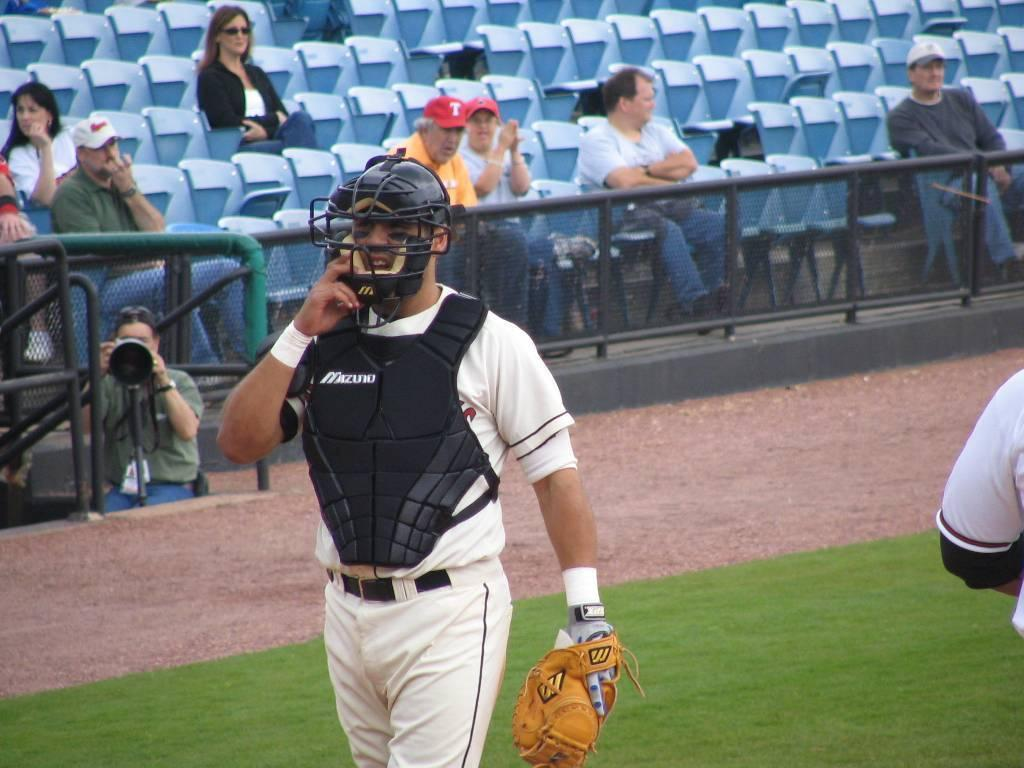<image>
Create a compact narrative representing the image presented. Man wearing a mask and a black vest which says Mizuto. 